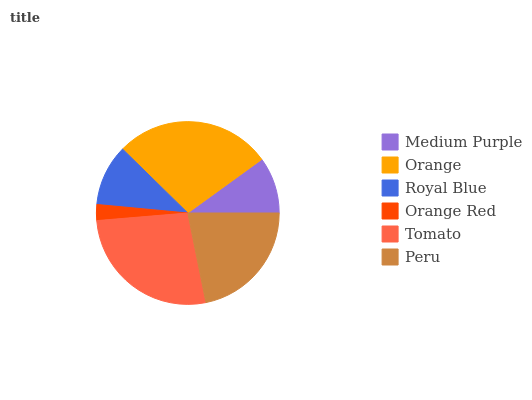Is Orange Red the minimum?
Answer yes or no. Yes. Is Orange the maximum?
Answer yes or no. Yes. Is Royal Blue the minimum?
Answer yes or no. No. Is Royal Blue the maximum?
Answer yes or no. No. Is Orange greater than Royal Blue?
Answer yes or no. Yes. Is Royal Blue less than Orange?
Answer yes or no. Yes. Is Royal Blue greater than Orange?
Answer yes or no. No. Is Orange less than Royal Blue?
Answer yes or no. No. Is Peru the high median?
Answer yes or no. Yes. Is Royal Blue the low median?
Answer yes or no. Yes. Is Orange the high median?
Answer yes or no. No. Is Medium Purple the low median?
Answer yes or no. No. 